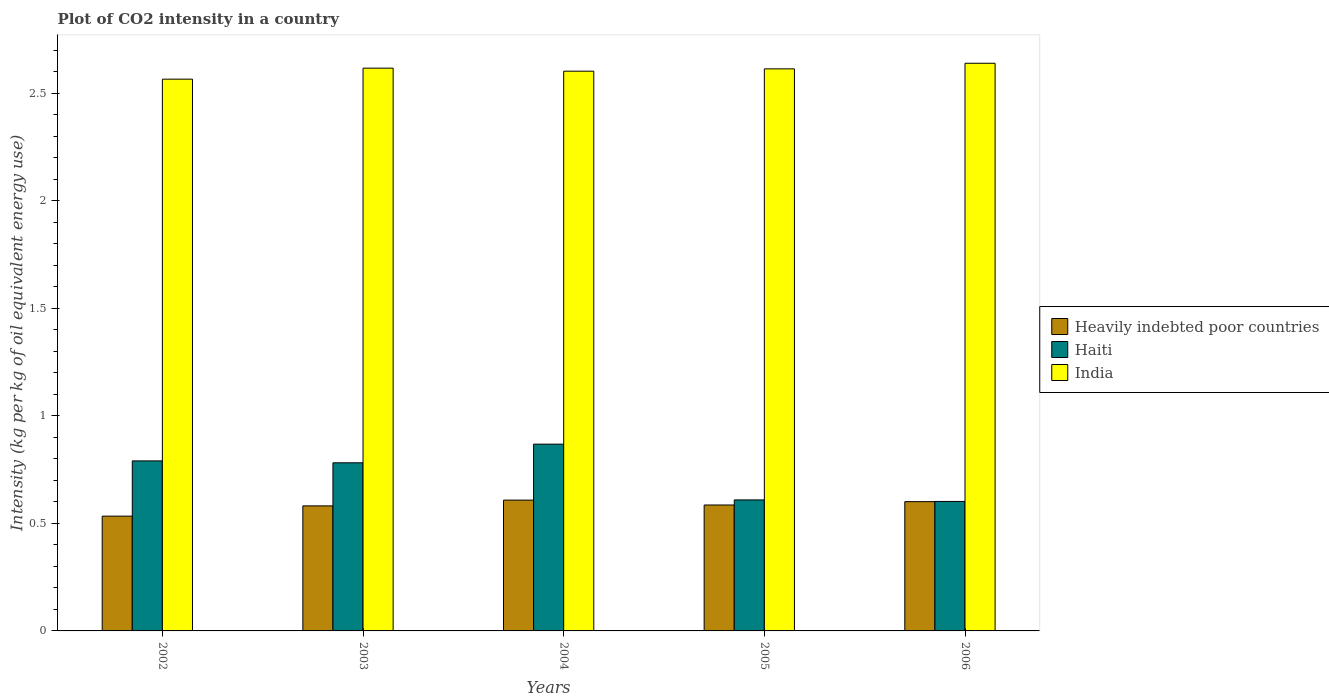Are the number of bars per tick equal to the number of legend labels?
Make the answer very short. Yes. Are the number of bars on each tick of the X-axis equal?
Offer a very short reply. Yes. How many bars are there on the 2nd tick from the left?
Offer a very short reply. 3. How many bars are there on the 5th tick from the right?
Give a very brief answer. 3. What is the CO2 intensity in in Haiti in 2005?
Your answer should be compact. 0.61. Across all years, what is the maximum CO2 intensity in in Haiti?
Give a very brief answer. 0.87. Across all years, what is the minimum CO2 intensity in in Haiti?
Your response must be concise. 0.6. In which year was the CO2 intensity in in Heavily indebted poor countries maximum?
Your answer should be very brief. 2004. In which year was the CO2 intensity in in Heavily indebted poor countries minimum?
Your answer should be compact. 2002. What is the total CO2 intensity in in Heavily indebted poor countries in the graph?
Your response must be concise. 2.91. What is the difference between the CO2 intensity in in Haiti in 2002 and that in 2005?
Make the answer very short. 0.18. What is the difference between the CO2 intensity in in Heavily indebted poor countries in 2005 and the CO2 intensity in in India in 2003?
Your answer should be very brief. -2.03. What is the average CO2 intensity in in Haiti per year?
Keep it short and to the point. 0.73. In the year 2002, what is the difference between the CO2 intensity in in India and CO2 intensity in in Heavily indebted poor countries?
Offer a terse response. 2.03. In how many years, is the CO2 intensity in in Haiti greater than 1.9 kg?
Your answer should be compact. 0. What is the ratio of the CO2 intensity in in Haiti in 2002 to that in 2004?
Ensure brevity in your answer.  0.91. Is the CO2 intensity in in India in 2002 less than that in 2005?
Provide a succinct answer. Yes. Is the difference between the CO2 intensity in in India in 2003 and 2004 greater than the difference between the CO2 intensity in in Heavily indebted poor countries in 2003 and 2004?
Offer a terse response. Yes. What is the difference between the highest and the second highest CO2 intensity in in Heavily indebted poor countries?
Give a very brief answer. 0.01. What is the difference between the highest and the lowest CO2 intensity in in India?
Offer a terse response. 0.07. In how many years, is the CO2 intensity in in Heavily indebted poor countries greater than the average CO2 intensity in in Heavily indebted poor countries taken over all years?
Your answer should be compact. 3. Is the sum of the CO2 intensity in in India in 2002 and 2003 greater than the maximum CO2 intensity in in Heavily indebted poor countries across all years?
Keep it short and to the point. Yes. What does the 1st bar from the left in 2003 represents?
Your response must be concise. Heavily indebted poor countries. What does the 3rd bar from the right in 2004 represents?
Ensure brevity in your answer.  Heavily indebted poor countries. Are all the bars in the graph horizontal?
Your answer should be compact. No. What is the title of the graph?
Your response must be concise. Plot of CO2 intensity in a country. Does "Grenada" appear as one of the legend labels in the graph?
Provide a succinct answer. No. What is the label or title of the Y-axis?
Give a very brief answer. Intensity (kg per kg of oil equivalent energy use). What is the Intensity (kg per kg of oil equivalent energy use) in Heavily indebted poor countries in 2002?
Your answer should be compact. 0.53. What is the Intensity (kg per kg of oil equivalent energy use) of Haiti in 2002?
Offer a terse response. 0.79. What is the Intensity (kg per kg of oil equivalent energy use) in India in 2002?
Make the answer very short. 2.57. What is the Intensity (kg per kg of oil equivalent energy use) in Heavily indebted poor countries in 2003?
Give a very brief answer. 0.58. What is the Intensity (kg per kg of oil equivalent energy use) in Haiti in 2003?
Give a very brief answer. 0.78. What is the Intensity (kg per kg of oil equivalent energy use) in India in 2003?
Your response must be concise. 2.62. What is the Intensity (kg per kg of oil equivalent energy use) in Heavily indebted poor countries in 2004?
Give a very brief answer. 0.61. What is the Intensity (kg per kg of oil equivalent energy use) in Haiti in 2004?
Your answer should be compact. 0.87. What is the Intensity (kg per kg of oil equivalent energy use) in India in 2004?
Your response must be concise. 2.6. What is the Intensity (kg per kg of oil equivalent energy use) in Heavily indebted poor countries in 2005?
Provide a short and direct response. 0.59. What is the Intensity (kg per kg of oil equivalent energy use) in Haiti in 2005?
Keep it short and to the point. 0.61. What is the Intensity (kg per kg of oil equivalent energy use) in India in 2005?
Keep it short and to the point. 2.61. What is the Intensity (kg per kg of oil equivalent energy use) of Heavily indebted poor countries in 2006?
Keep it short and to the point. 0.6. What is the Intensity (kg per kg of oil equivalent energy use) in Haiti in 2006?
Keep it short and to the point. 0.6. What is the Intensity (kg per kg of oil equivalent energy use) of India in 2006?
Keep it short and to the point. 2.64. Across all years, what is the maximum Intensity (kg per kg of oil equivalent energy use) in Heavily indebted poor countries?
Ensure brevity in your answer.  0.61. Across all years, what is the maximum Intensity (kg per kg of oil equivalent energy use) in Haiti?
Give a very brief answer. 0.87. Across all years, what is the maximum Intensity (kg per kg of oil equivalent energy use) of India?
Make the answer very short. 2.64. Across all years, what is the minimum Intensity (kg per kg of oil equivalent energy use) in Heavily indebted poor countries?
Make the answer very short. 0.53. Across all years, what is the minimum Intensity (kg per kg of oil equivalent energy use) of Haiti?
Offer a terse response. 0.6. Across all years, what is the minimum Intensity (kg per kg of oil equivalent energy use) in India?
Offer a terse response. 2.57. What is the total Intensity (kg per kg of oil equivalent energy use) of Heavily indebted poor countries in the graph?
Your response must be concise. 2.91. What is the total Intensity (kg per kg of oil equivalent energy use) of Haiti in the graph?
Your answer should be compact. 3.65. What is the total Intensity (kg per kg of oil equivalent energy use) of India in the graph?
Ensure brevity in your answer.  13.04. What is the difference between the Intensity (kg per kg of oil equivalent energy use) of Heavily indebted poor countries in 2002 and that in 2003?
Keep it short and to the point. -0.05. What is the difference between the Intensity (kg per kg of oil equivalent energy use) in Haiti in 2002 and that in 2003?
Your response must be concise. 0.01. What is the difference between the Intensity (kg per kg of oil equivalent energy use) in India in 2002 and that in 2003?
Your answer should be compact. -0.05. What is the difference between the Intensity (kg per kg of oil equivalent energy use) of Heavily indebted poor countries in 2002 and that in 2004?
Give a very brief answer. -0.07. What is the difference between the Intensity (kg per kg of oil equivalent energy use) of Haiti in 2002 and that in 2004?
Provide a succinct answer. -0.08. What is the difference between the Intensity (kg per kg of oil equivalent energy use) of India in 2002 and that in 2004?
Offer a terse response. -0.04. What is the difference between the Intensity (kg per kg of oil equivalent energy use) of Heavily indebted poor countries in 2002 and that in 2005?
Keep it short and to the point. -0.05. What is the difference between the Intensity (kg per kg of oil equivalent energy use) of Haiti in 2002 and that in 2005?
Provide a short and direct response. 0.18. What is the difference between the Intensity (kg per kg of oil equivalent energy use) of India in 2002 and that in 2005?
Your response must be concise. -0.05. What is the difference between the Intensity (kg per kg of oil equivalent energy use) in Heavily indebted poor countries in 2002 and that in 2006?
Offer a terse response. -0.07. What is the difference between the Intensity (kg per kg of oil equivalent energy use) of Haiti in 2002 and that in 2006?
Your response must be concise. 0.19. What is the difference between the Intensity (kg per kg of oil equivalent energy use) of India in 2002 and that in 2006?
Provide a short and direct response. -0.07. What is the difference between the Intensity (kg per kg of oil equivalent energy use) of Heavily indebted poor countries in 2003 and that in 2004?
Your answer should be compact. -0.03. What is the difference between the Intensity (kg per kg of oil equivalent energy use) in Haiti in 2003 and that in 2004?
Offer a very short reply. -0.09. What is the difference between the Intensity (kg per kg of oil equivalent energy use) of India in 2003 and that in 2004?
Ensure brevity in your answer.  0.01. What is the difference between the Intensity (kg per kg of oil equivalent energy use) of Heavily indebted poor countries in 2003 and that in 2005?
Your response must be concise. -0. What is the difference between the Intensity (kg per kg of oil equivalent energy use) in Haiti in 2003 and that in 2005?
Offer a terse response. 0.17. What is the difference between the Intensity (kg per kg of oil equivalent energy use) in India in 2003 and that in 2005?
Your answer should be compact. 0. What is the difference between the Intensity (kg per kg of oil equivalent energy use) of Heavily indebted poor countries in 2003 and that in 2006?
Your response must be concise. -0.02. What is the difference between the Intensity (kg per kg of oil equivalent energy use) of Haiti in 2003 and that in 2006?
Your answer should be compact. 0.18. What is the difference between the Intensity (kg per kg of oil equivalent energy use) of India in 2003 and that in 2006?
Your answer should be very brief. -0.02. What is the difference between the Intensity (kg per kg of oil equivalent energy use) of Heavily indebted poor countries in 2004 and that in 2005?
Your answer should be compact. 0.02. What is the difference between the Intensity (kg per kg of oil equivalent energy use) of Haiti in 2004 and that in 2005?
Your response must be concise. 0.26. What is the difference between the Intensity (kg per kg of oil equivalent energy use) of India in 2004 and that in 2005?
Ensure brevity in your answer.  -0.01. What is the difference between the Intensity (kg per kg of oil equivalent energy use) in Heavily indebted poor countries in 2004 and that in 2006?
Keep it short and to the point. 0.01. What is the difference between the Intensity (kg per kg of oil equivalent energy use) of Haiti in 2004 and that in 2006?
Your answer should be compact. 0.27. What is the difference between the Intensity (kg per kg of oil equivalent energy use) of India in 2004 and that in 2006?
Offer a very short reply. -0.04. What is the difference between the Intensity (kg per kg of oil equivalent energy use) in Heavily indebted poor countries in 2005 and that in 2006?
Ensure brevity in your answer.  -0.02. What is the difference between the Intensity (kg per kg of oil equivalent energy use) of Haiti in 2005 and that in 2006?
Your answer should be compact. 0.01. What is the difference between the Intensity (kg per kg of oil equivalent energy use) in India in 2005 and that in 2006?
Offer a very short reply. -0.03. What is the difference between the Intensity (kg per kg of oil equivalent energy use) in Heavily indebted poor countries in 2002 and the Intensity (kg per kg of oil equivalent energy use) in Haiti in 2003?
Make the answer very short. -0.25. What is the difference between the Intensity (kg per kg of oil equivalent energy use) of Heavily indebted poor countries in 2002 and the Intensity (kg per kg of oil equivalent energy use) of India in 2003?
Give a very brief answer. -2.08. What is the difference between the Intensity (kg per kg of oil equivalent energy use) in Haiti in 2002 and the Intensity (kg per kg of oil equivalent energy use) in India in 2003?
Your answer should be very brief. -1.83. What is the difference between the Intensity (kg per kg of oil equivalent energy use) of Heavily indebted poor countries in 2002 and the Intensity (kg per kg of oil equivalent energy use) of Haiti in 2004?
Make the answer very short. -0.33. What is the difference between the Intensity (kg per kg of oil equivalent energy use) in Heavily indebted poor countries in 2002 and the Intensity (kg per kg of oil equivalent energy use) in India in 2004?
Provide a succinct answer. -2.07. What is the difference between the Intensity (kg per kg of oil equivalent energy use) of Haiti in 2002 and the Intensity (kg per kg of oil equivalent energy use) of India in 2004?
Keep it short and to the point. -1.81. What is the difference between the Intensity (kg per kg of oil equivalent energy use) of Heavily indebted poor countries in 2002 and the Intensity (kg per kg of oil equivalent energy use) of Haiti in 2005?
Keep it short and to the point. -0.08. What is the difference between the Intensity (kg per kg of oil equivalent energy use) of Heavily indebted poor countries in 2002 and the Intensity (kg per kg of oil equivalent energy use) of India in 2005?
Provide a succinct answer. -2.08. What is the difference between the Intensity (kg per kg of oil equivalent energy use) of Haiti in 2002 and the Intensity (kg per kg of oil equivalent energy use) of India in 2005?
Offer a terse response. -1.82. What is the difference between the Intensity (kg per kg of oil equivalent energy use) in Heavily indebted poor countries in 2002 and the Intensity (kg per kg of oil equivalent energy use) in Haiti in 2006?
Offer a terse response. -0.07. What is the difference between the Intensity (kg per kg of oil equivalent energy use) in Heavily indebted poor countries in 2002 and the Intensity (kg per kg of oil equivalent energy use) in India in 2006?
Your response must be concise. -2.11. What is the difference between the Intensity (kg per kg of oil equivalent energy use) in Haiti in 2002 and the Intensity (kg per kg of oil equivalent energy use) in India in 2006?
Your answer should be compact. -1.85. What is the difference between the Intensity (kg per kg of oil equivalent energy use) in Heavily indebted poor countries in 2003 and the Intensity (kg per kg of oil equivalent energy use) in Haiti in 2004?
Make the answer very short. -0.29. What is the difference between the Intensity (kg per kg of oil equivalent energy use) of Heavily indebted poor countries in 2003 and the Intensity (kg per kg of oil equivalent energy use) of India in 2004?
Your answer should be compact. -2.02. What is the difference between the Intensity (kg per kg of oil equivalent energy use) of Haiti in 2003 and the Intensity (kg per kg of oil equivalent energy use) of India in 2004?
Offer a terse response. -1.82. What is the difference between the Intensity (kg per kg of oil equivalent energy use) in Heavily indebted poor countries in 2003 and the Intensity (kg per kg of oil equivalent energy use) in Haiti in 2005?
Your response must be concise. -0.03. What is the difference between the Intensity (kg per kg of oil equivalent energy use) in Heavily indebted poor countries in 2003 and the Intensity (kg per kg of oil equivalent energy use) in India in 2005?
Offer a very short reply. -2.03. What is the difference between the Intensity (kg per kg of oil equivalent energy use) in Haiti in 2003 and the Intensity (kg per kg of oil equivalent energy use) in India in 2005?
Your answer should be compact. -1.83. What is the difference between the Intensity (kg per kg of oil equivalent energy use) in Heavily indebted poor countries in 2003 and the Intensity (kg per kg of oil equivalent energy use) in Haiti in 2006?
Give a very brief answer. -0.02. What is the difference between the Intensity (kg per kg of oil equivalent energy use) of Heavily indebted poor countries in 2003 and the Intensity (kg per kg of oil equivalent energy use) of India in 2006?
Provide a succinct answer. -2.06. What is the difference between the Intensity (kg per kg of oil equivalent energy use) of Haiti in 2003 and the Intensity (kg per kg of oil equivalent energy use) of India in 2006?
Provide a succinct answer. -1.86. What is the difference between the Intensity (kg per kg of oil equivalent energy use) of Heavily indebted poor countries in 2004 and the Intensity (kg per kg of oil equivalent energy use) of Haiti in 2005?
Offer a terse response. -0. What is the difference between the Intensity (kg per kg of oil equivalent energy use) in Heavily indebted poor countries in 2004 and the Intensity (kg per kg of oil equivalent energy use) in India in 2005?
Offer a terse response. -2.01. What is the difference between the Intensity (kg per kg of oil equivalent energy use) in Haiti in 2004 and the Intensity (kg per kg of oil equivalent energy use) in India in 2005?
Make the answer very short. -1.75. What is the difference between the Intensity (kg per kg of oil equivalent energy use) in Heavily indebted poor countries in 2004 and the Intensity (kg per kg of oil equivalent energy use) in Haiti in 2006?
Offer a terse response. 0.01. What is the difference between the Intensity (kg per kg of oil equivalent energy use) of Heavily indebted poor countries in 2004 and the Intensity (kg per kg of oil equivalent energy use) of India in 2006?
Make the answer very short. -2.03. What is the difference between the Intensity (kg per kg of oil equivalent energy use) of Haiti in 2004 and the Intensity (kg per kg of oil equivalent energy use) of India in 2006?
Your response must be concise. -1.77. What is the difference between the Intensity (kg per kg of oil equivalent energy use) in Heavily indebted poor countries in 2005 and the Intensity (kg per kg of oil equivalent energy use) in Haiti in 2006?
Ensure brevity in your answer.  -0.02. What is the difference between the Intensity (kg per kg of oil equivalent energy use) in Heavily indebted poor countries in 2005 and the Intensity (kg per kg of oil equivalent energy use) in India in 2006?
Ensure brevity in your answer.  -2.05. What is the difference between the Intensity (kg per kg of oil equivalent energy use) in Haiti in 2005 and the Intensity (kg per kg of oil equivalent energy use) in India in 2006?
Provide a short and direct response. -2.03. What is the average Intensity (kg per kg of oil equivalent energy use) of Heavily indebted poor countries per year?
Make the answer very short. 0.58. What is the average Intensity (kg per kg of oil equivalent energy use) in Haiti per year?
Ensure brevity in your answer.  0.73. What is the average Intensity (kg per kg of oil equivalent energy use) of India per year?
Your answer should be very brief. 2.61. In the year 2002, what is the difference between the Intensity (kg per kg of oil equivalent energy use) in Heavily indebted poor countries and Intensity (kg per kg of oil equivalent energy use) in Haiti?
Make the answer very short. -0.26. In the year 2002, what is the difference between the Intensity (kg per kg of oil equivalent energy use) in Heavily indebted poor countries and Intensity (kg per kg of oil equivalent energy use) in India?
Offer a terse response. -2.03. In the year 2002, what is the difference between the Intensity (kg per kg of oil equivalent energy use) of Haiti and Intensity (kg per kg of oil equivalent energy use) of India?
Give a very brief answer. -1.78. In the year 2003, what is the difference between the Intensity (kg per kg of oil equivalent energy use) in Heavily indebted poor countries and Intensity (kg per kg of oil equivalent energy use) in Haiti?
Your answer should be compact. -0.2. In the year 2003, what is the difference between the Intensity (kg per kg of oil equivalent energy use) in Heavily indebted poor countries and Intensity (kg per kg of oil equivalent energy use) in India?
Your answer should be compact. -2.04. In the year 2003, what is the difference between the Intensity (kg per kg of oil equivalent energy use) of Haiti and Intensity (kg per kg of oil equivalent energy use) of India?
Offer a very short reply. -1.84. In the year 2004, what is the difference between the Intensity (kg per kg of oil equivalent energy use) of Heavily indebted poor countries and Intensity (kg per kg of oil equivalent energy use) of Haiti?
Your response must be concise. -0.26. In the year 2004, what is the difference between the Intensity (kg per kg of oil equivalent energy use) in Heavily indebted poor countries and Intensity (kg per kg of oil equivalent energy use) in India?
Your answer should be compact. -2. In the year 2004, what is the difference between the Intensity (kg per kg of oil equivalent energy use) in Haiti and Intensity (kg per kg of oil equivalent energy use) in India?
Offer a terse response. -1.73. In the year 2005, what is the difference between the Intensity (kg per kg of oil equivalent energy use) of Heavily indebted poor countries and Intensity (kg per kg of oil equivalent energy use) of Haiti?
Keep it short and to the point. -0.02. In the year 2005, what is the difference between the Intensity (kg per kg of oil equivalent energy use) in Heavily indebted poor countries and Intensity (kg per kg of oil equivalent energy use) in India?
Ensure brevity in your answer.  -2.03. In the year 2005, what is the difference between the Intensity (kg per kg of oil equivalent energy use) of Haiti and Intensity (kg per kg of oil equivalent energy use) of India?
Keep it short and to the point. -2.01. In the year 2006, what is the difference between the Intensity (kg per kg of oil equivalent energy use) of Heavily indebted poor countries and Intensity (kg per kg of oil equivalent energy use) of Haiti?
Your response must be concise. -0. In the year 2006, what is the difference between the Intensity (kg per kg of oil equivalent energy use) in Heavily indebted poor countries and Intensity (kg per kg of oil equivalent energy use) in India?
Your answer should be compact. -2.04. In the year 2006, what is the difference between the Intensity (kg per kg of oil equivalent energy use) of Haiti and Intensity (kg per kg of oil equivalent energy use) of India?
Your answer should be compact. -2.04. What is the ratio of the Intensity (kg per kg of oil equivalent energy use) of Heavily indebted poor countries in 2002 to that in 2003?
Your response must be concise. 0.92. What is the ratio of the Intensity (kg per kg of oil equivalent energy use) in Haiti in 2002 to that in 2003?
Your answer should be compact. 1.01. What is the ratio of the Intensity (kg per kg of oil equivalent energy use) in India in 2002 to that in 2003?
Give a very brief answer. 0.98. What is the ratio of the Intensity (kg per kg of oil equivalent energy use) of Heavily indebted poor countries in 2002 to that in 2004?
Make the answer very short. 0.88. What is the ratio of the Intensity (kg per kg of oil equivalent energy use) in Haiti in 2002 to that in 2004?
Your answer should be compact. 0.91. What is the ratio of the Intensity (kg per kg of oil equivalent energy use) of India in 2002 to that in 2004?
Your answer should be very brief. 0.99. What is the ratio of the Intensity (kg per kg of oil equivalent energy use) of Heavily indebted poor countries in 2002 to that in 2005?
Your answer should be compact. 0.91. What is the ratio of the Intensity (kg per kg of oil equivalent energy use) in Haiti in 2002 to that in 2005?
Give a very brief answer. 1.3. What is the ratio of the Intensity (kg per kg of oil equivalent energy use) in India in 2002 to that in 2005?
Make the answer very short. 0.98. What is the ratio of the Intensity (kg per kg of oil equivalent energy use) in Heavily indebted poor countries in 2002 to that in 2006?
Your response must be concise. 0.89. What is the ratio of the Intensity (kg per kg of oil equivalent energy use) of Haiti in 2002 to that in 2006?
Give a very brief answer. 1.31. What is the ratio of the Intensity (kg per kg of oil equivalent energy use) in Heavily indebted poor countries in 2003 to that in 2004?
Offer a terse response. 0.96. What is the ratio of the Intensity (kg per kg of oil equivalent energy use) in Haiti in 2003 to that in 2004?
Your answer should be compact. 0.9. What is the ratio of the Intensity (kg per kg of oil equivalent energy use) of India in 2003 to that in 2004?
Provide a short and direct response. 1.01. What is the ratio of the Intensity (kg per kg of oil equivalent energy use) of Heavily indebted poor countries in 2003 to that in 2005?
Your response must be concise. 0.99. What is the ratio of the Intensity (kg per kg of oil equivalent energy use) in Haiti in 2003 to that in 2005?
Your answer should be compact. 1.28. What is the ratio of the Intensity (kg per kg of oil equivalent energy use) in India in 2003 to that in 2005?
Offer a very short reply. 1. What is the ratio of the Intensity (kg per kg of oil equivalent energy use) in Heavily indebted poor countries in 2003 to that in 2006?
Keep it short and to the point. 0.97. What is the ratio of the Intensity (kg per kg of oil equivalent energy use) of Haiti in 2003 to that in 2006?
Offer a terse response. 1.3. What is the ratio of the Intensity (kg per kg of oil equivalent energy use) in India in 2003 to that in 2006?
Provide a short and direct response. 0.99. What is the ratio of the Intensity (kg per kg of oil equivalent energy use) in Heavily indebted poor countries in 2004 to that in 2005?
Provide a short and direct response. 1.04. What is the ratio of the Intensity (kg per kg of oil equivalent energy use) of Haiti in 2004 to that in 2005?
Provide a succinct answer. 1.43. What is the ratio of the Intensity (kg per kg of oil equivalent energy use) in India in 2004 to that in 2005?
Provide a succinct answer. 1. What is the ratio of the Intensity (kg per kg of oil equivalent energy use) of Heavily indebted poor countries in 2004 to that in 2006?
Give a very brief answer. 1.01. What is the ratio of the Intensity (kg per kg of oil equivalent energy use) in Haiti in 2004 to that in 2006?
Provide a succinct answer. 1.44. What is the ratio of the Intensity (kg per kg of oil equivalent energy use) of India in 2004 to that in 2006?
Make the answer very short. 0.99. What is the ratio of the Intensity (kg per kg of oil equivalent energy use) of Heavily indebted poor countries in 2005 to that in 2006?
Make the answer very short. 0.97. What is the ratio of the Intensity (kg per kg of oil equivalent energy use) in Haiti in 2005 to that in 2006?
Provide a short and direct response. 1.01. What is the ratio of the Intensity (kg per kg of oil equivalent energy use) in India in 2005 to that in 2006?
Offer a terse response. 0.99. What is the difference between the highest and the second highest Intensity (kg per kg of oil equivalent energy use) in Heavily indebted poor countries?
Offer a terse response. 0.01. What is the difference between the highest and the second highest Intensity (kg per kg of oil equivalent energy use) in Haiti?
Your response must be concise. 0.08. What is the difference between the highest and the second highest Intensity (kg per kg of oil equivalent energy use) in India?
Your answer should be compact. 0.02. What is the difference between the highest and the lowest Intensity (kg per kg of oil equivalent energy use) of Heavily indebted poor countries?
Your response must be concise. 0.07. What is the difference between the highest and the lowest Intensity (kg per kg of oil equivalent energy use) of Haiti?
Give a very brief answer. 0.27. What is the difference between the highest and the lowest Intensity (kg per kg of oil equivalent energy use) in India?
Your response must be concise. 0.07. 